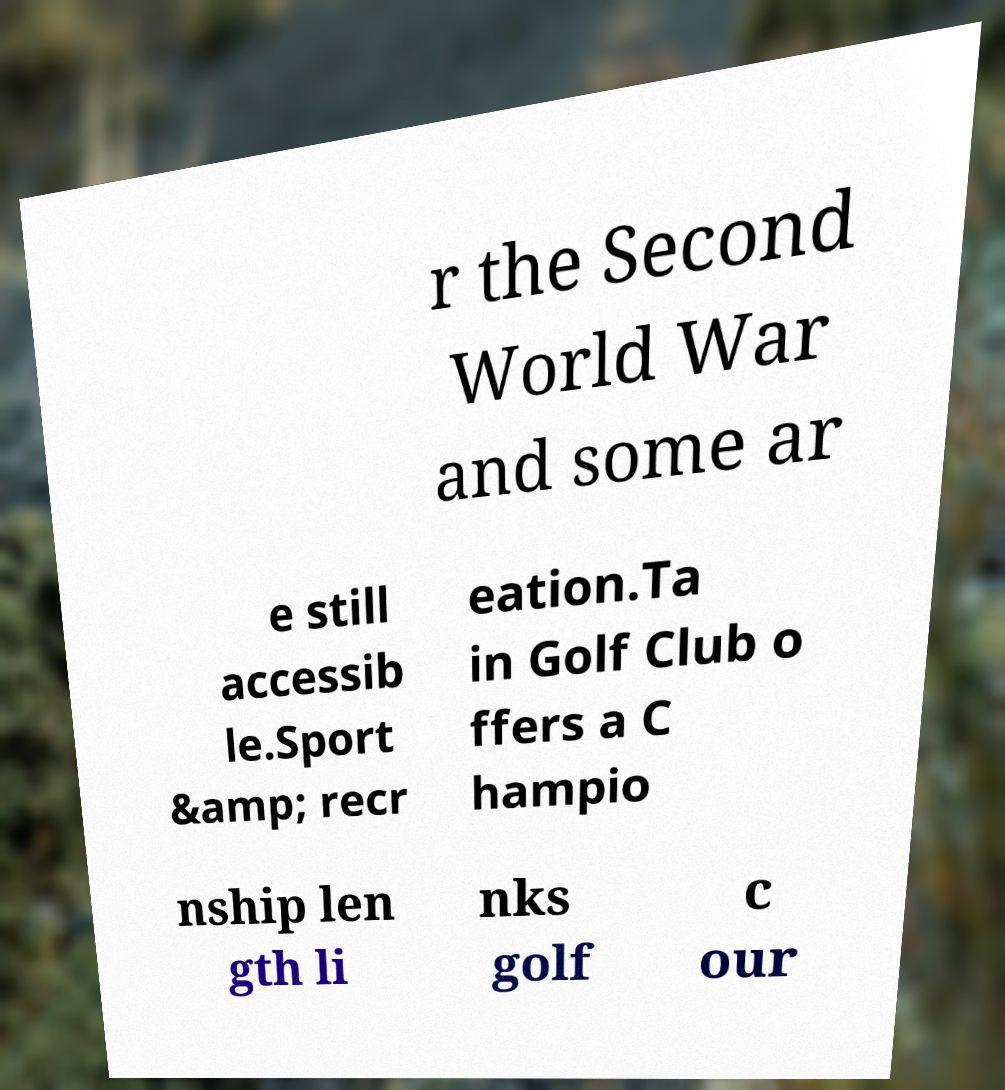Please identify and transcribe the text found in this image. r the Second World War and some ar e still accessib le.Sport &amp; recr eation.Ta in Golf Club o ffers a C hampio nship len gth li nks golf c our 